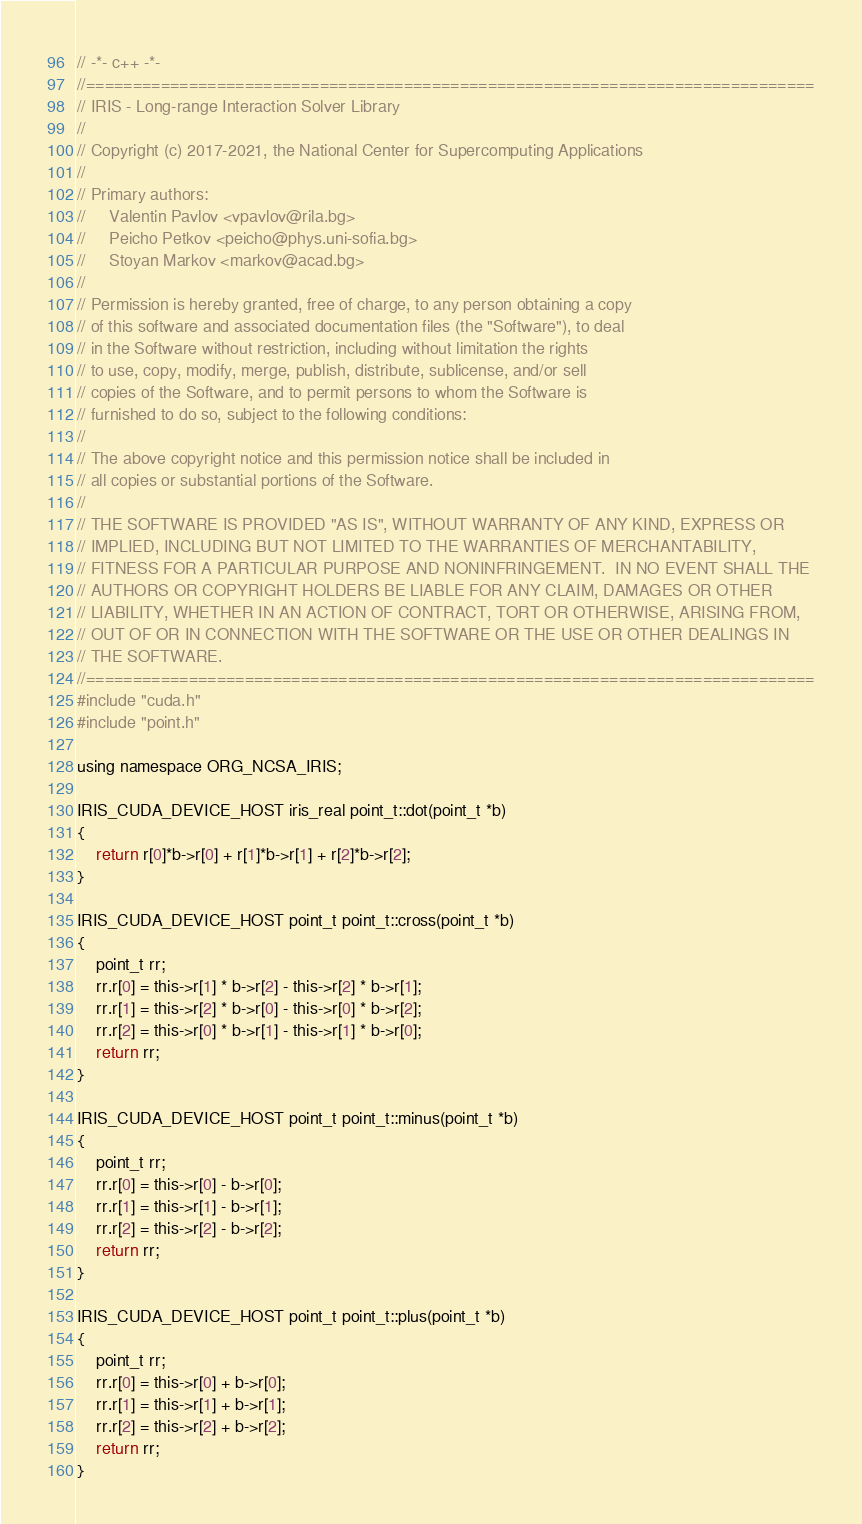Convert code to text. <code><loc_0><loc_0><loc_500><loc_500><_Cuda_>// -*- c++ -*-
//==============================================================================
// IRIS - Long-range Interaction Solver Library
//
// Copyright (c) 2017-2021, the National Center for Supercomputing Applications
//
// Primary authors:
//     Valentin Pavlov <vpavlov@rila.bg>
//     Peicho Petkov <peicho@phys.uni-sofia.bg>
//     Stoyan Markov <markov@acad.bg>
//
// Permission is hereby granted, free of charge, to any person obtaining a copy
// of this software and associated documentation files (the "Software"), to deal
// in the Software without restriction, including without limitation the rights
// to use, copy, modify, merge, publish, distribute, sublicense, and/or sell
// copies of the Software, and to permit persons to whom the Software is
// furnished to do so, subject to the following conditions:
//
// The above copyright notice and this permission notice shall be included in
// all copies or substantial portions of the Software.
//
// THE SOFTWARE IS PROVIDED "AS IS", WITHOUT WARRANTY OF ANY KIND, EXPRESS OR
// IMPLIED, INCLUDING BUT NOT LIMITED TO THE WARRANTIES OF MERCHANTABILITY,
// FITNESS FOR A PARTICULAR PURPOSE AND NONINFRINGEMENT.  IN NO EVENT SHALL THE
// AUTHORS OR COPYRIGHT HOLDERS BE LIABLE FOR ANY CLAIM, DAMAGES OR OTHER
// LIABILITY, WHETHER IN AN ACTION OF CONTRACT, TORT OR OTHERWISE, ARISING FROM,
// OUT OF OR IN CONNECTION WITH THE SOFTWARE OR THE USE OR OTHER DEALINGS IN
// THE SOFTWARE.
//==============================================================================
#include "cuda.h"
#include "point.h"

using namespace ORG_NCSA_IRIS;

IRIS_CUDA_DEVICE_HOST iris_real point_t::dot(point_t *b)
{
    return r[0]*b->r[0] + r[1]*b->r[1] + r[2]*b->r[2];
}

IRIS_CUDA_DEVICE_HOST point_t point_t::cross(point_t *b)
{
    point_t rr;
    rr.r[0] = this->r[1] * b->r[2] - this->r[2] * b->r[1];
    rr.r[1] = this->r[2] * b->r[0] - this->r[0] * b->r[2];
    rr.r[2] = this->r[0] * b->r[1] - this->r[1] * b->r[0];
    return rr;
}

IRIS_CUDA_DEVICE_HOST point_t point_t::minus(point_t *b)
{
    point_t rr;
    rr.r[0] = this->r[0] - b->r[0];
    rr.r[1] = this->r[1] - b->r[1];
    rr.r[2] = this->r[2] - b->r[2];
    return rr;
}

IRIS_CUDA_DEVICE_HOST point_t point_t::plus(point_t *b)
{
    point_t rr;
    rr.r[0] = this->r[0] + b->r[0];
    rr.r[1] = this->r[1] + b->r[1];
    rr.r[2] = this->r[2] + b->r[2];
    return rr;
}
</code> 